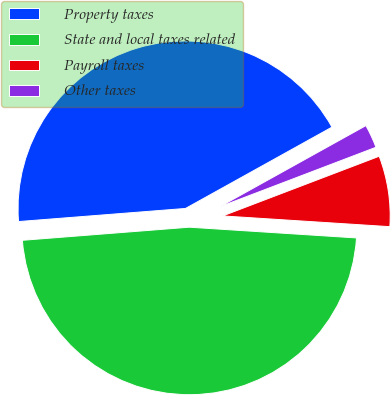<chart> <loc_0><loc_0><loc_500><loc_500><pie_chart><fcel>Property taxes<fcel>State and local taxes related<fcel>Payroll taxes<fcel>Other taxes<nl><fcel>43.18%<fcel>47.73%<fcel>6.82%<fcel>2.27%<nl></chart> 